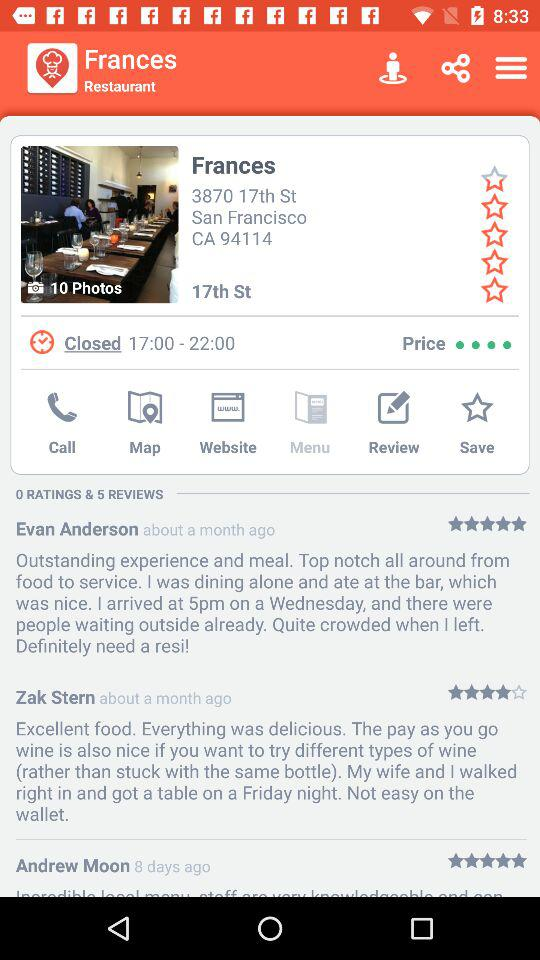How many stars are given by Evan Anderson? The number of stars given by Evan Anderson is 5. 